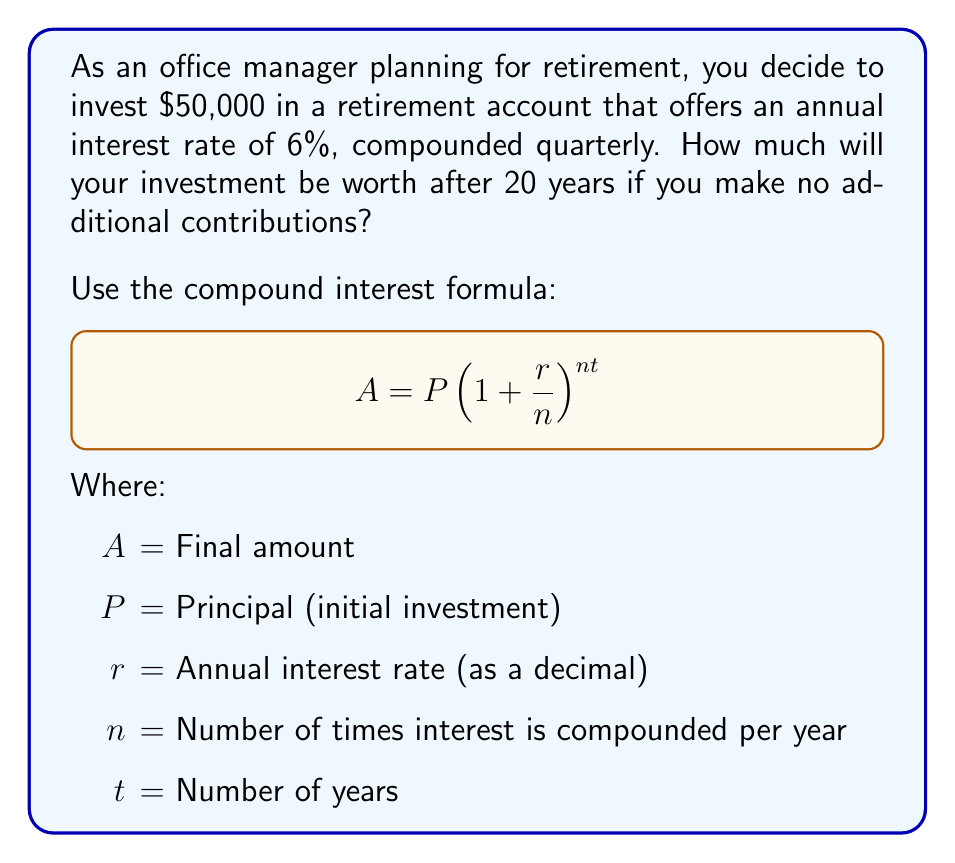What is the answer to this math problem? Let's break down the problem and solve it step-by-step:

1. Identify the given values:
   $P = \$50,000$ (initial investment)
   $r = 0.06$ (6% annual interest rate)
   $n = 4$ (compounded quarterly, so 4 times per year)
   $t = 20$ years

2. Plug these values into the compound interest formula:
   $$A = 50000(1 + \frac{0.06}{4})^{4 \cdot 20}$$

3. Simplify the expression inside the parentheses:
   $$A = 50000(1 + 0.015)^{80}$$

4. Calculate the value inside the parentheses:
   $$A = 50000(1.015)^{80}$$

5. Use a calculator to compute the result:
   $$A = 50000 \cdot 3.3102...$$
   $$A = 165,510.26$$

6. Round to the nearest cent:
   $$A = \$165,510.26$$

Therefore, after 20 years, your initial investment of $50,000 will grow to $165,510.26.
Answer: $165,510.26 